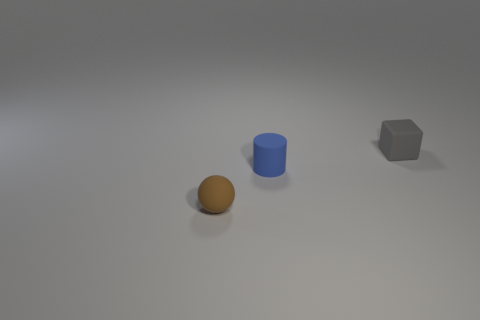What number of green things are tiny spheres or tiny matte cylinders?
Ensure brevity in your answer.  0. How many small things are both behind the tiny cylinder and in front of the cube?
Offer a terse response. 0. Is the ball made of the same material as the tiny cylinder?
Offer a terse response. Yes. There is a gray object that is the same size as the blue object; what shape is it?
Provide a succinct answer. Cube. Is the number of small blue cylinders greater than the number of small gray metallic balls?
Your answer should be very brief. Yes. There is a object that is to the right of the small matte sphere and in front of the rubber cube; what material is it made of?
Keep it short and to the point. Rubber. How many other objects are there of the same material as the block?
Your response must be concise. 2. How many matte objects have the same color as the tiny cube?
Your answer should be very brief. 0. How many shiny things are either brown balls or small blue objects?
Offer a terse response. 0. Do the tiny brown rubber thing and the object behind the small cylinder have the same shape?
Provide a short and direct response. No. 